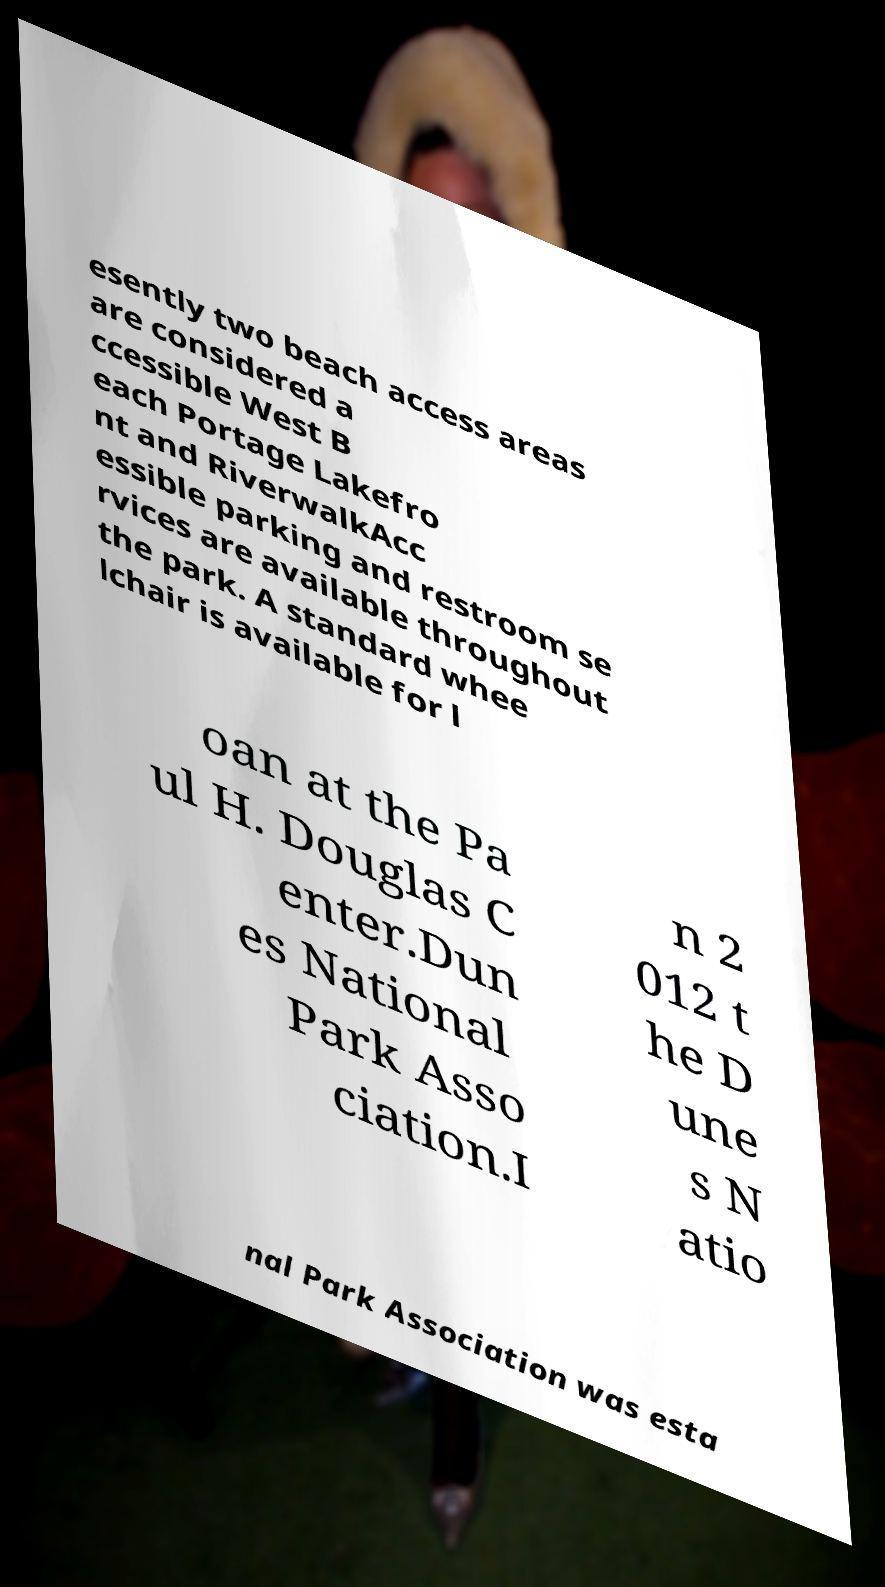Could you extract and type out the text from this image? esently two beach access areas are considered a ccessible West B each Portage Lakefro nt and RiverwalkAcc essible parking and restroom se rvices are available throughout the park. A standard whee lchair is available for l oan at the Pa ul H. Douglas C enter.Dun es National Park Asso ciation.I n 2 012 t he D une s N atio nal Park Association was esta 